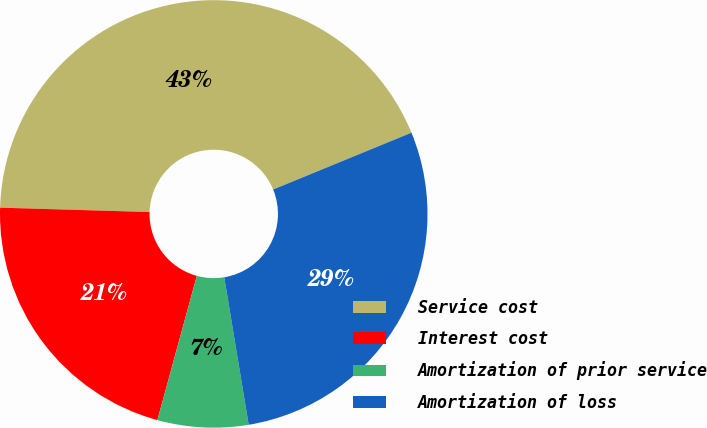Convert chart to OTSL. <chart><loc_0><loc_0><loc_500><loc_500><pie_chart><fcel>Service cost<fcel>Interest cost<fcel>Amortization of prior service<fcel>Amortization of loss<nl><fcel>43.33%<fcel>21.22%<fcel>6.86%<fcel>28.59%<nl></chart> 